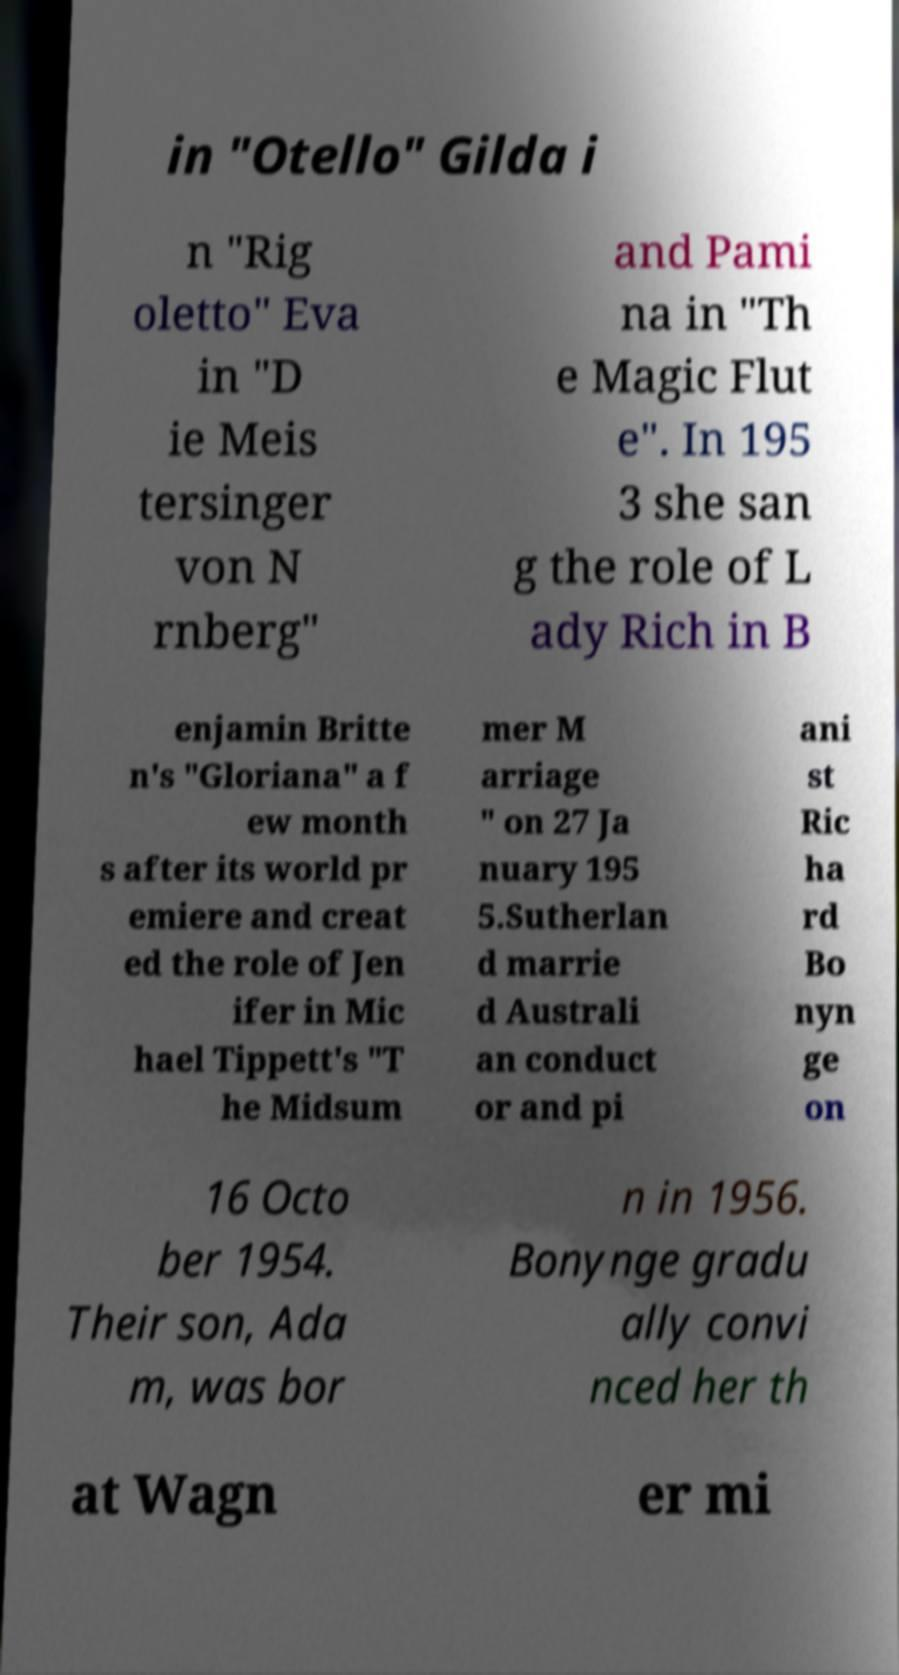Can you accurately transcribe the text from the provided image for me? in "Otello" Gilda i n "Rig oletto" Eva in "D ie Meis tersinger von N rnberg" and Pami na in "Th e Magic Flut e". In 195 3 she san g the role of L ady Rich in B enjamin Britte n's "Gloriana" a f ew month s after its world pr emiere and creat ed the role of Jen ifer in Mic hael Tippett's "T he Midsum mer M arriage " on 27 Ja nuary 195 5.Sutherlan d marrie d Australi an conduct or and pi ani st Ric ha rd Bo nyn ge on 16 Octo ber 1954. Their son, Ada m, was bor n in 1956. Bonynge gradu ally convi nced her th at Wagn er mi 